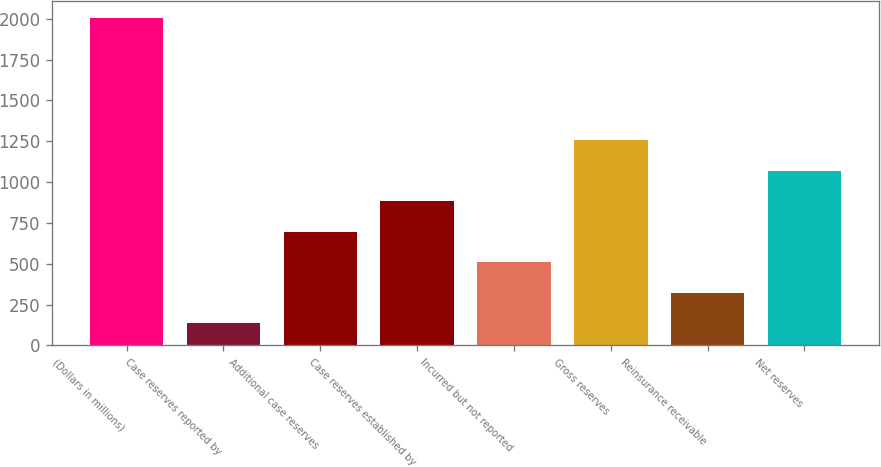<chart> <loc_0><loc_0><loc_500><loc_500><bar_chart><fcel>(Dollars in millions)<fcel>Case reserves reported by<fcel>Additional case reserves<fcel>Case reserves established by<fcel>Incurred but not reported<fcel>Gross reserves<fcel>Reinsurance receivable<fcel>Net reserves<nl><fcel>2006<fcel>135.6<fcel>696.72<fcel>883.76<fcel>509.68<fcel>1257.84<fcel>322.64<fcel>1070.8<nl></chart> 